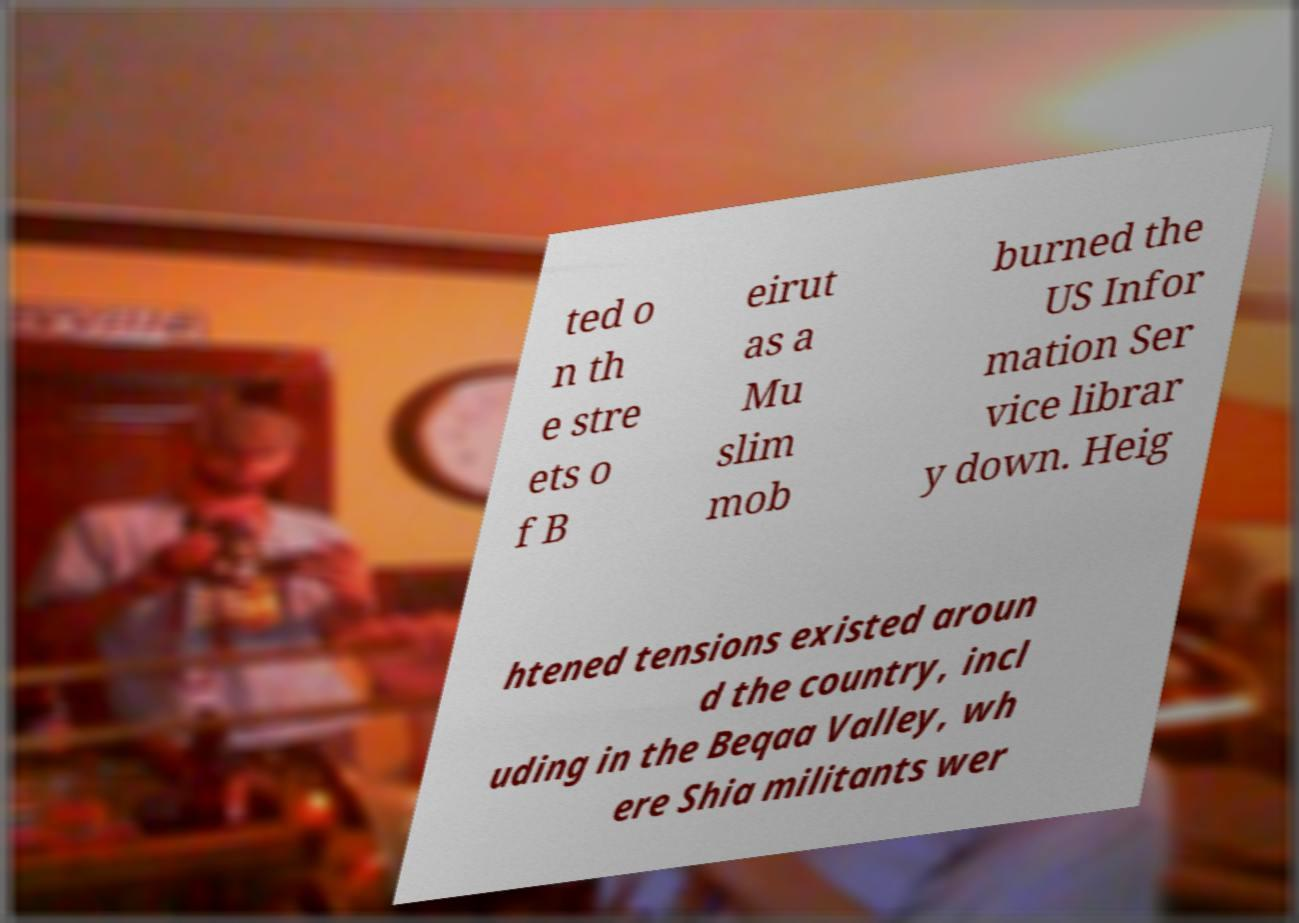There's text embedded in this image that I need extracted. Can you transcribe it verbatim? ted o n th e stre ets o f B eirut as a Mu slim mob burned the US Infor mation Ser vice librar y down. Heig htened tensions existed aroun d the country, incl uding in the Beqaa Valley, wh ere Shia militants wer 